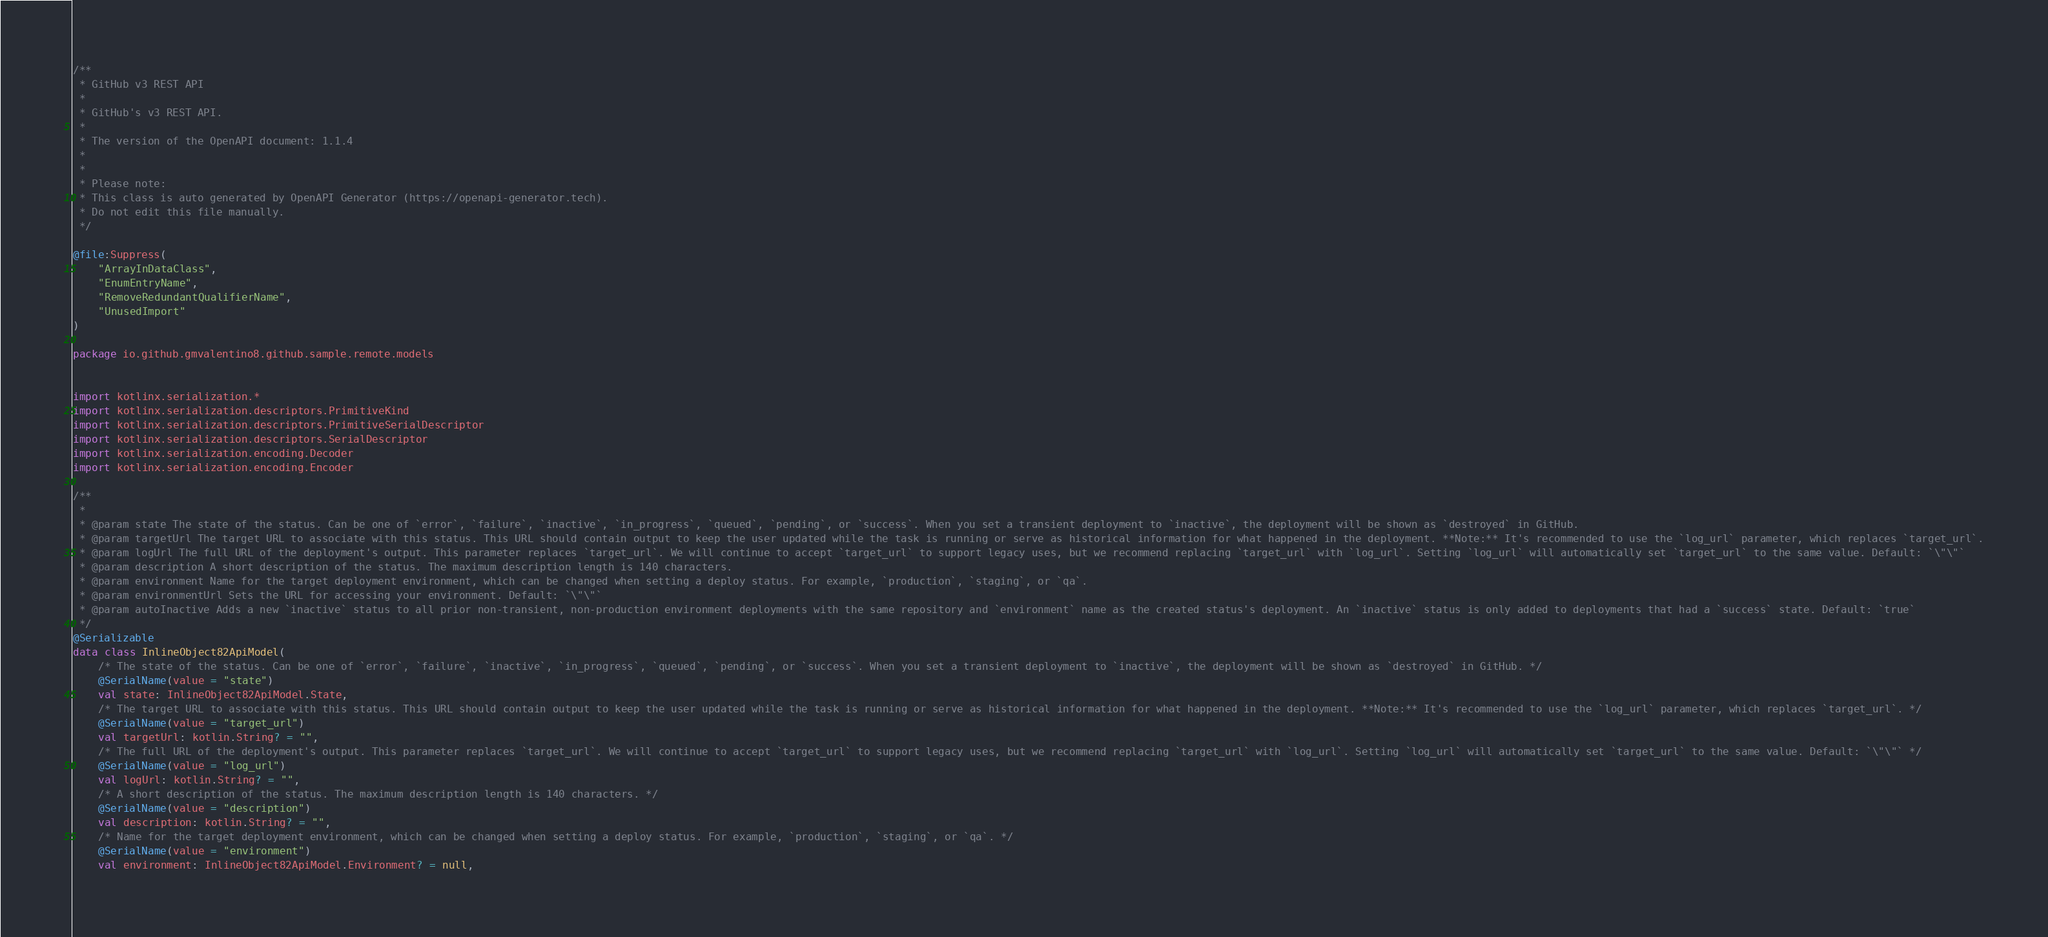Convert code to text. <code><loc_0><loc_0><loc_500><loc_500><_Kotlin_>/**
 * GitHub v3 REST API
 *
 * GitHub's v3 REST API.
 *
 * The version of the OpenAPI document: 1.1.4
 * 
 *
 * Please note:
 * This class is auto generated by OpenAPI Generator (https://openapi-generator.tech).
 * Do not edit this file manually.
 */

@file:Suppress(
    "ArrayInDataClass",
    "EnumEntryName",
    "RemoveRedundantQualifierName",
    "UnusedImport"
)

package io.github.gmvalentino8.github.sample.remote.models


import kotlinx.serialization.*
import kotlinx.serialization.descriptors.PrimitiveKind
import kotlinx.serialization.descriptors.PrimitiveSerialDescriptor
import kotlinx.serialization.descriptors.SerialDescriptor
import kotlinx.serialization.encoding.Decoder
import kotlinx.serialization.encoding.Encoder

/**
 * 
 * @param state The state of the status. Can be one of `error`, `failure`, `inactive`, `in_progress`, `queued`, `pending`, or `success`. When you set a transient deployment to `inactive`, the deployment will be shown as `destroyed` in GitHub.
 * @param targetUrl The target URL to associate with this status. This URL should contain output to keep the user updated while the task is running or serve as historical information for what happened in the deployment. **Note:** It's recommended to use the `log_url` parameter, which replaces `target_url`.
 * @param logUrl The full URL of the deployment's output. This parameter replaces `target_url`. We will continue to accept `target_url` to support legacy uses, but we recommend replacing `target_url` with `log_url`. Setting `log_url` will automatically set `target_url` to the same value. Default: `\"\"`
 * @param description A short description of the status. The maximum description length is 140 characters.
 * @param environment Name for the target deployment environment, which can be changed when setting a deploy status. For example, `production`, `staging`, or `qa`.
 * @param environmentUrl Sets the URL for accessing your environment. Default: `\"\"`
 * @param autoInactive Adds a new `inactive` status to all prior non-transient, non-production environment deployments with the same repository and `environment` name as the created status's deployment. An `inactive` status is only added to deployments that had a `success` state. Default: `true`
 */
@Serializable
data class InlineObject82ApiModel(
    /* The state of the status. Can be one of `error`, `failure`, `inactive`, `in_progress`, `queued`, `pending`, or `success`. When you set a transient deployment to `inactive`, the deployment will be shown as `destroyed` in GitHub. */
    @SerialName(value = "state")
    val state: InlineObject82ApiModel.State,
    /* The target URL to associate with this status. This URL should contain output to keep the user updated while the task is running or serve as historical information for what happened in the deployment. **Note:** It's recommended to use the `log_url` parameter, which replaces `target_url`. */
    @SerialName(value = "target_url")
    val targetUrl: kotlin.String? = "",
    /* The full URL of the deployment's output. This parameter replaces `target_url`. We will continue to accept `target_url` to support legacy uses, but we recommend replacing `target_url` with `log_url`. Setting `log_url` will automatically set `target_url` to the same value. Default: `\"\"` */
    @SerialName(value = "log_url")
    val logUrl: kotlin.String? = "",
    /* A short description of the status. The maximum description length is 140 characters. */
    @SerialName(value = "description")
    val description: kotlin.String? = "",
    /* Name for the target deployment environment, which can be changed when setting a deploy status. For example, `production`, `staging`, or `qa`. */
    @SerialName(value = "environment")
    val environment: InlineObject82ApiModel.Environment? = null,</code> 